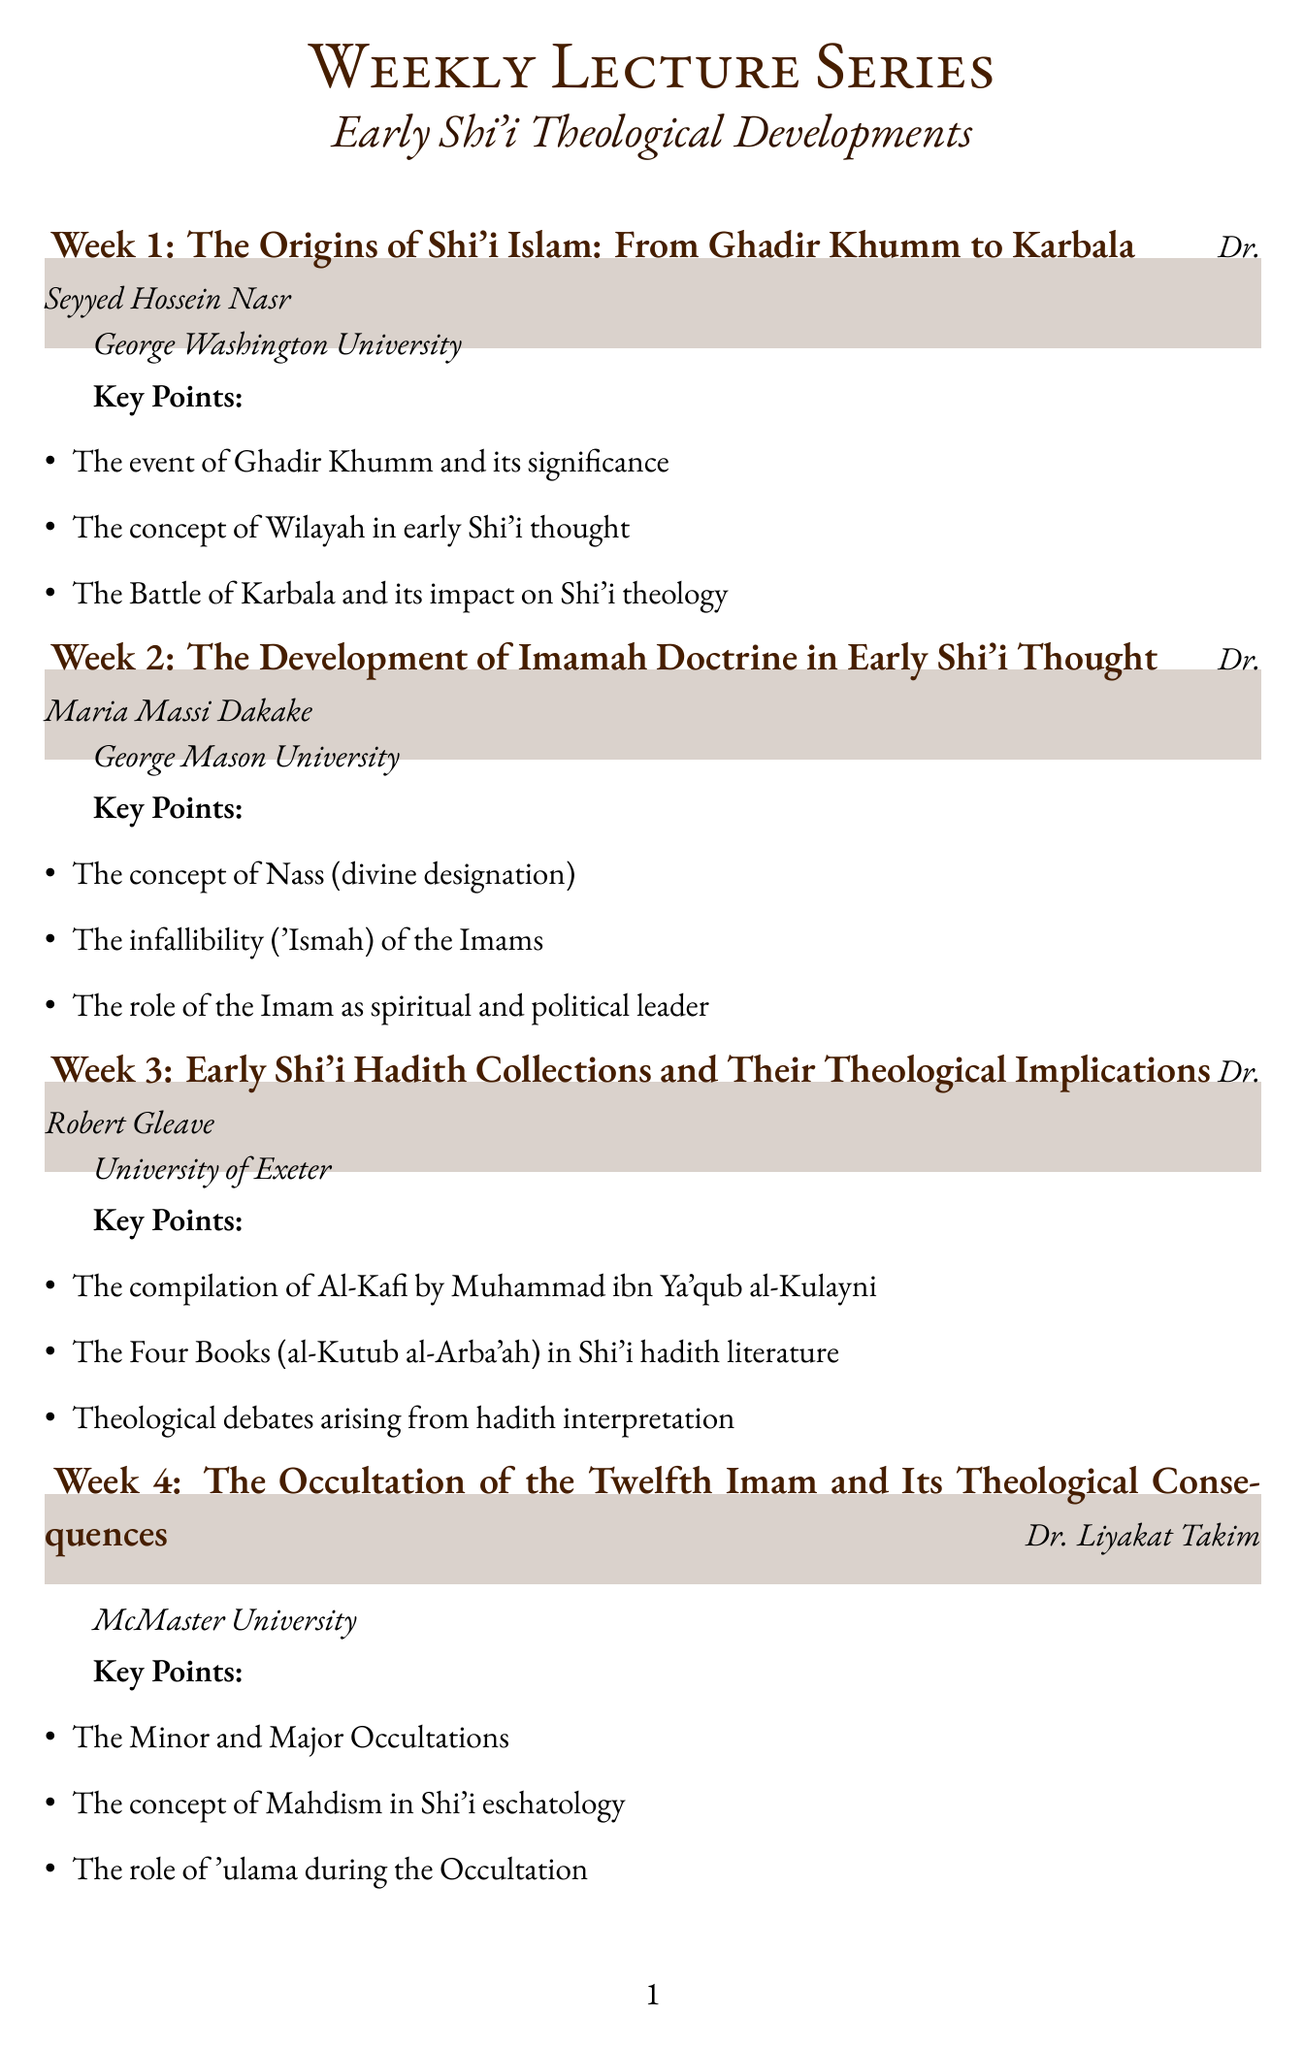What is the title of the first lecture? The title of the first lecture is found in the "topic" section of the first entry in the document.
Answer: The Origins of Shi'i Islam: From Ghadir Khumm to Karbala Who is the speaker for the fourth lecture? The speaker's name can be found in the details of the fourth lecture entry in the document.
Answer: Dr. Liyakat Takim How many weeks are covered in the lecture series? The total number of weeks is indicated by the number of entries in the "lecture_series" section of the document.
Answer: 8 What institution is Dr. Maria Massi Dakake affiliated with? The institution is specified in the details of the second lecture entry in the document.
Answer: George Mason University What key point is associated with the sixth week lecture? The key points are listed under each week's details, and at least one key point from the sixth week can provide the answer.
Answer: The emergence of the Akhbari school Which lecture discusses the concept of Mahdism? The specific lecture that addresses Mahdism is noted in its title and key points in the document.
Answer: The Occultation of the Twelfth Imam and Its Theological Consequences What is the main theme of the seventh week lecture? The theme can be determined by looking at the "topic" of the seventh week's lecture entry.
Answer: Mysticism and Gnosis in Early Shi'i Thought 